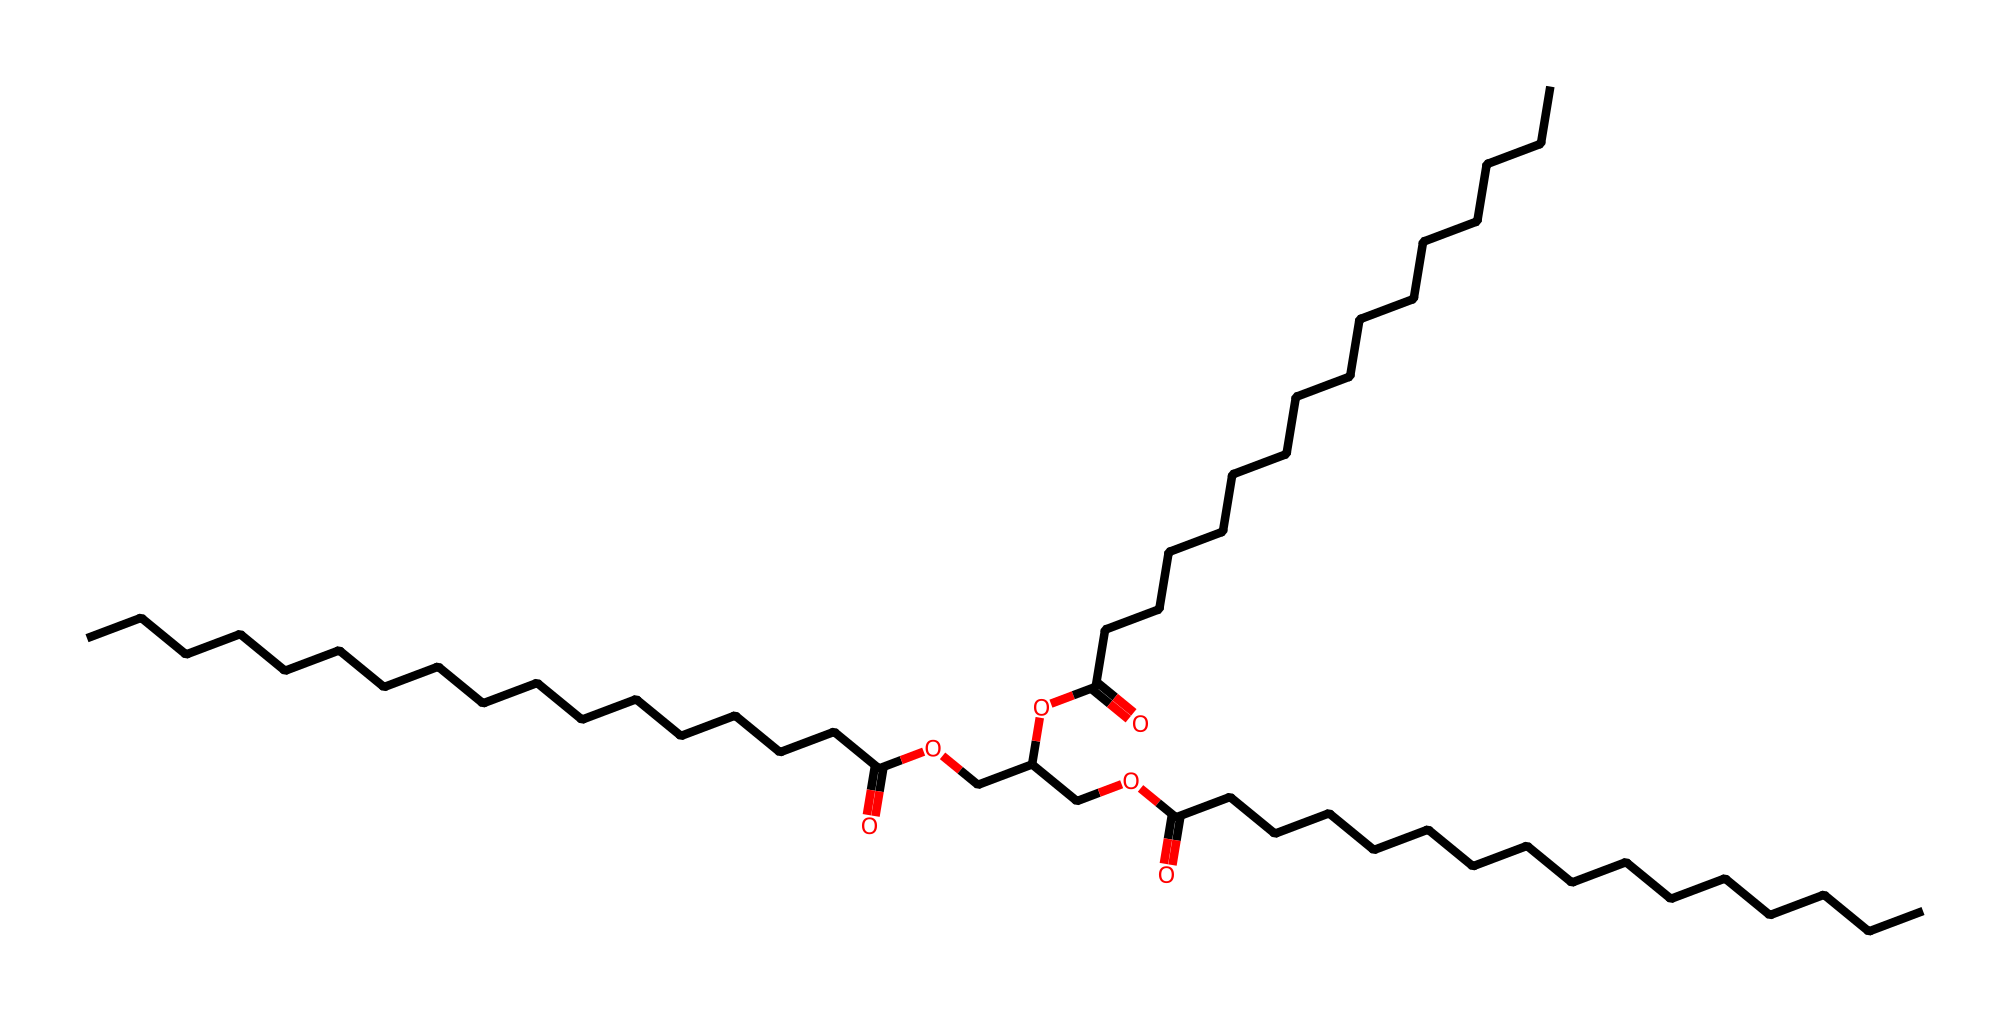How many carbon atoms are in this molecule? Counting the "C" representations in the SMILES notation, we identify 31 distinct carbon atoms.
Answer: 31 What functional group is present in this chemical? In the structure, we can identify the carboxylic acid functional groups represented by "C(=O)O," which indicates the presence of -COOH groups.
Answer: carboxylic acid How many ester linkages are present in this molecule? The SMILES representation contains three instances of "OC(=O)," indicating the presence of three ester linkages, as they involve the connection of alcohol and acid components.
Answer: 3 What is the total number of oxygen atoms in this chemical? By examining the SMILES notation, we see that there are four occurrences of "O," which represents a total of four oxygen atoms in the molecule.
Answer: 4 Is this chemical likely to be polar or non-polar? The molecule contains both polar (like carboxylic acid) and non-polar components (the long carbon chains), but the long carbon chains suggest it may be mostly non-polar overall.
Answer: non-polar What type of liquid would this chemical likely be categorized as? Given its composition and the presence of long hydrocarbon chains alongside functional groups, this chemical can be categorized as a lubricant, specifically a low-emission lubricant for engines.
Answer: lubricant 